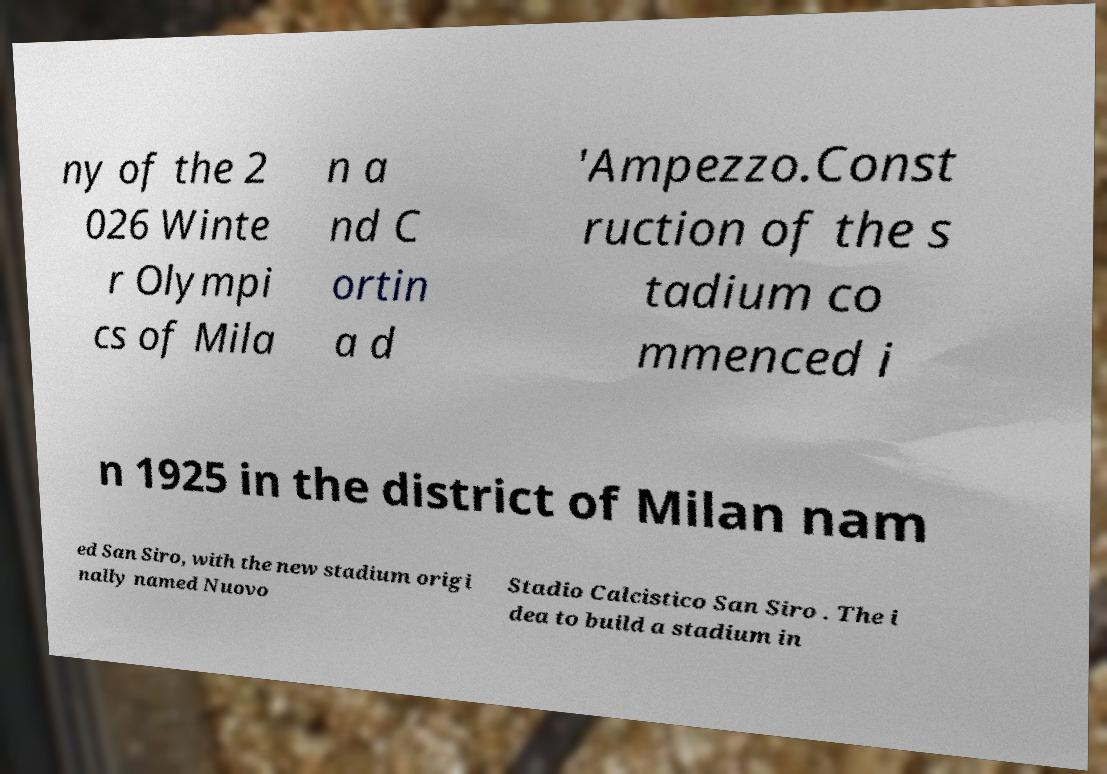Can you accurately transcribe the text from the provided image for me? ny of the 2 026 Winte r Olympi cs of Mila n a nd C ortin a d 'Ampezzo.Const ruction of the s tadium co mmenced i n 1925 in the district of Milan nam ed San Siro, with the new stadium origi nally named Nuovo Stadio Calcistico San Siro . The i dea to build a stadium in 